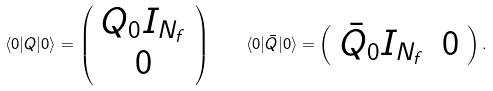Convert formula to latex. <formula><loc_0><loc_0><loc_500><loc_500>\langle 0 | Q | 0 \rangle = \left ( \begin{array} { c } { { Q _ { 0 } I _ { N _ { f } } } } \\ { 0 } \end{array} \right ) \quad \langle 0 | \bar { Q } | 0 \rangle = \left ( \begin{array} { c c } { { \bar { Q } _ { 0 } I _ { N _ { f } } } } & { 0 } \end{array} \right ) .</formula> 